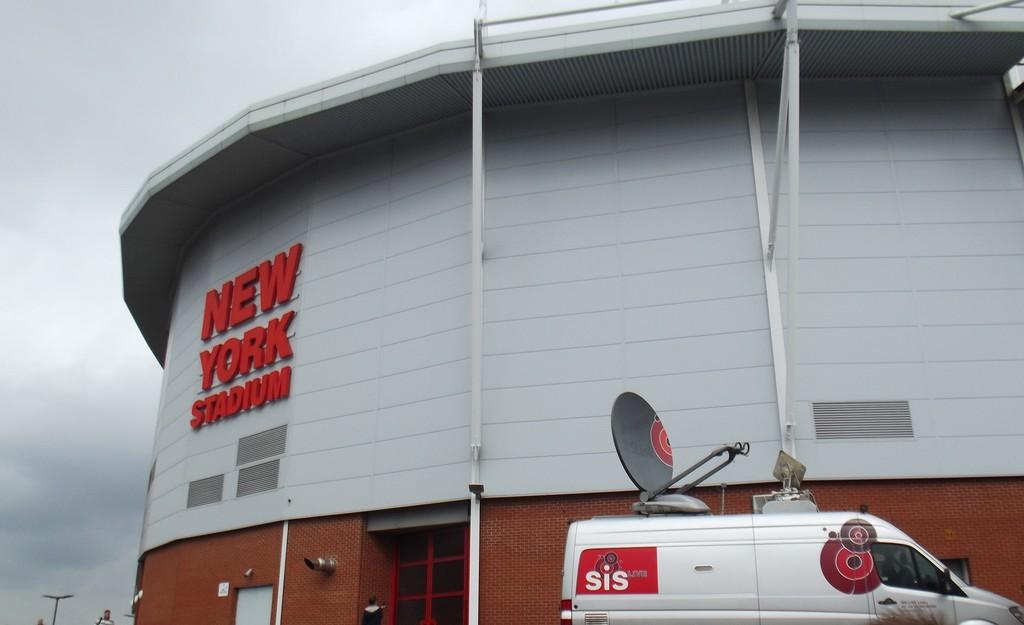<image>
Render a clear and concise summary of the photo. A white SIS van sits along side of the New York Stadium. 